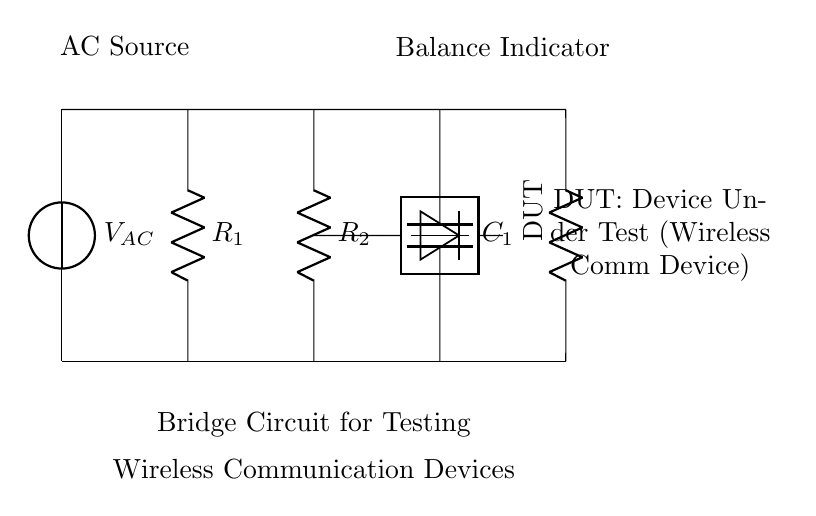What is the type of voltage source in the circuit? The circuit shows an AC source labeled V_AC, indicating that it supplies alternating current.
Answer: AC What component connects to the device under test? The circuit diagram indicates that there is a resistor labeled "DUT," which stands for Device Under Test, connected to the end of the circuit.
Answer: Resistor How many resistors are present in this circuit? There are two resistors labeled R1 and R2 in the circuit diagram, which can be seen parallelly arranged.
Answer: Two What is the function of C1 in the circuit? The capacitor labeled C1 is used in this circuit to store and release electrical energy, contributing to the balance of the bridge circuit.
Answer: Capacitor What indicates the balance condition in this circuit? The balance indicator, located at the output of the circuit after the connection from the detector, shows whether the bridge is balanced based on the measurements taken from the DUT.
Answer: Balance Indicator What is the purpose of this bridge circuit? The bridge circuit is designed specifically to test the quality of wireless communication devices, ensuring their operational efficiency and performance.
Answer: Testing Where does the AC source connect in the circuit? The AC source connects at the top to the two horizontal lines framing the circuit, leading to the vertical connection of the resistors and capacitor.
Answer: Top 